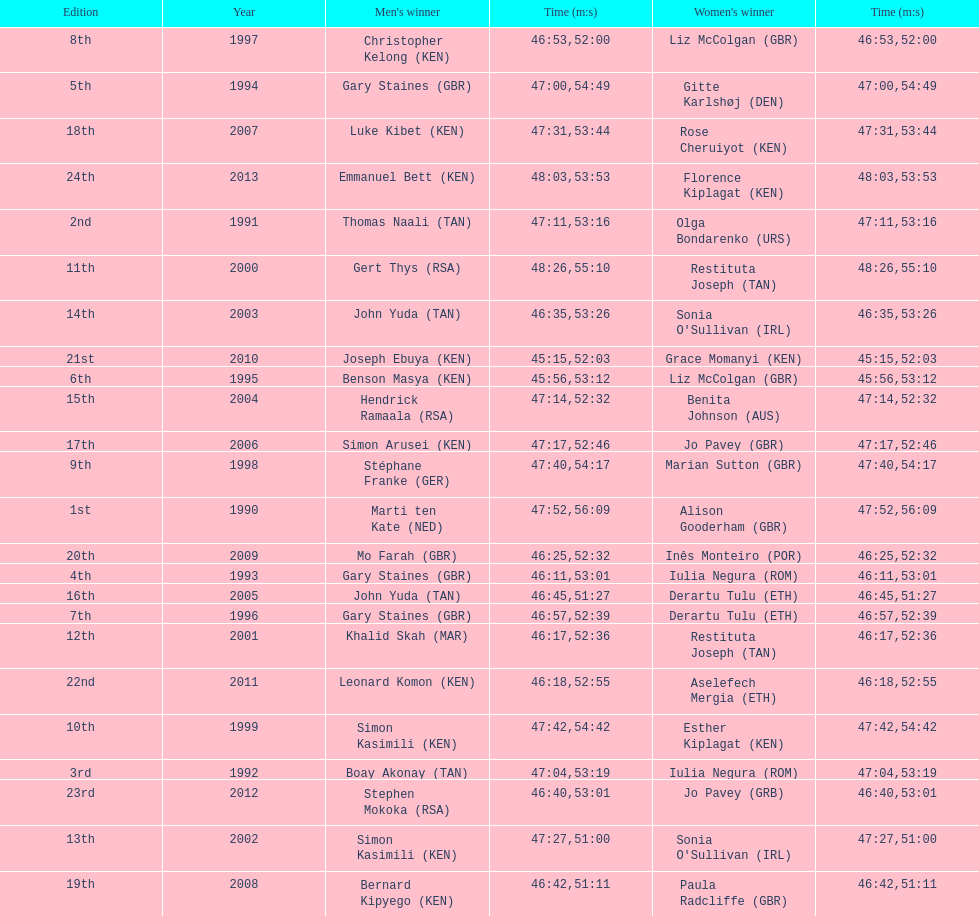Number of men's winners with a finish time under 46:58 12. 